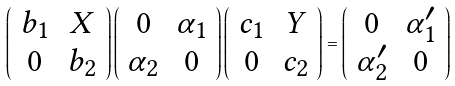Convert formula to latex. <formula><loc_0><loc_0><loc_500><loc_500>\left ( \begin{array} { c c } b _ { 1 } & X \\ 0 & b _ { 2 } \end{array} \right ) \left ( \begin{array} { c c } 0 & \alpha _ { 1 } \\ \alpha _ { 2 } & 0 \end{array} \right ) \left ( \begin{array} { c c } c _ { 1 } & Y \\ 0 & c _ { 2 } \end{array} \right ) = \left ( \begin{array} { c c } 0 & \alpha _ { 1 } ^ { \prime } \\ \alpha _ { 2 } ^ { \prime } & 0 \end{array} \right )</formula> 